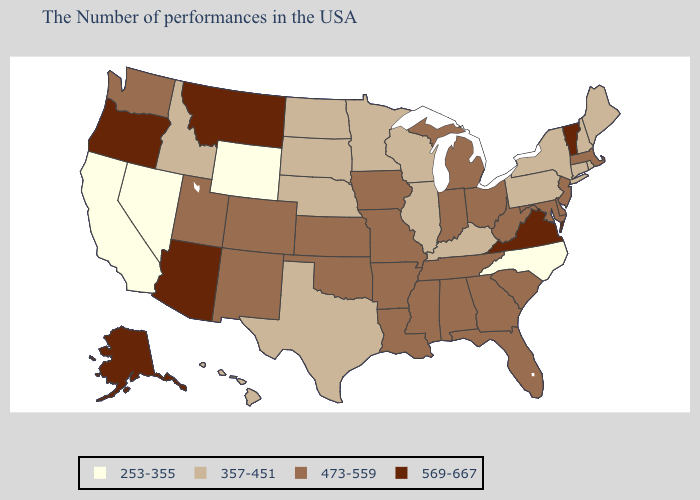What is the lowest value in states that border Colorado?
Keep it brief. 253-355. What is the lowest value in the MidWest?
Be succinct. 357-451. Does California have the lowest value in the West?
Concise answer only. Yes. Name the states that have a value in the range 357-451?
Answer briefly. Maine, Rhode Island, New Hampshire, Connecticut, New York, Pennsylvania, Kentucky, Wisconsin, Illinois, Minnesota, Nebraska, Texas, South Dakota, North Dakota, Idaho, Hawaii. Does Delaware have the same value as Vermont?
Give a very brief answer. No. What is the value of Delaware?
Answer briefly. 473-559. Name the states that have a value in the range 357-451?
Quick response, please. Maine, Rhode Island, New Hampshire, Connecticut, New York, Pennsylvania, Kentucky, Wisconsin, Illinois, Minnesota, Nebraska, Texas, South Dakota, North Dakota, Idaho, Hawaii. What is the value of Oregon?
Give a very brief answer. 569-667. What is the value of Minnesota?
Give a very brief answer. 357-451. Name the states that have a value in the range 357-451?
Be succinct. Maine, Rhode Island, New Hampshire, Connecticut, New York, Pennsylvania, Kentucky, Wisconsin, Illinois, Minnesota, Nebraska, Texas, South Dakota, North Dakota, Idaho, Hawaii. What is the value of Louisiana?
Quick response, please. 473-559. Does North Carolina have the lowest value in the USA?
Be succinct. Yes. What is the value of Alabama?
Answer briefly. 473-559. Name the states that have a value in the range 569-667?
Short answer required. Vermont, Virginia, Montana, Arizona, Oregon, Alaska. What is the value of North Dakota?
Answer briefly. 357-451. 